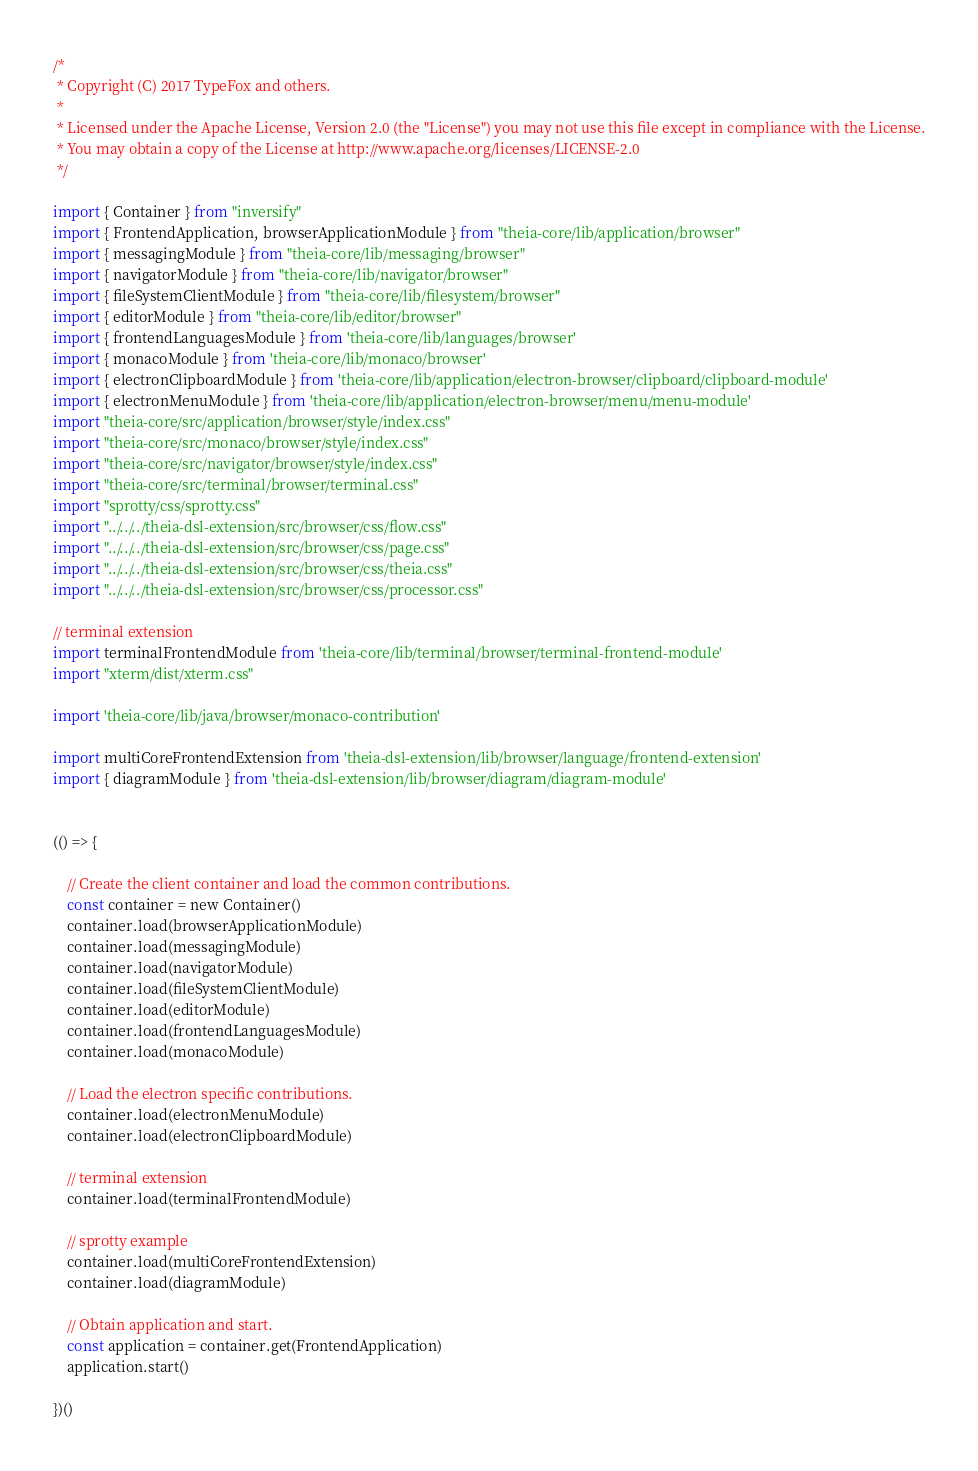Convert code to text. <code><loc_0><loc_0><loc_500><loc_500><_TypeScript_>/*
 * Copyright (C) 2017 TypeFox and others.
 *
 * Licensed under the Apache License, Version 2.0 (the "License") you may not use this file except in compliance with the License.
 * You may obtain a copy of the License at http://www.apache.org/licenses/LICENSE-2.0
 */

import { Container } from "inversify"
import { FrontendApplication, browserApplicationModule } from "theia-core/lib/application/browser"
import { messagingModule } from "theia-core/lib/messaging/browser"
import { navigatorModule } from "theia-core/lib/navigator/browser"
import { fileSystemClientModule } from "theia-core/lib/filesystem/browser"
import { editorModule } from "theia-core/lib/editor/browser"
import { frontendLanguagesModule } from 'theia-core/lib/languages/browser'
import { monacoModule } from 'theia-core/lib/monaco/browser'
import { electronClipboardModule } from 'theia-core/lib/application/electron-browser/clipboard/clipboard-module'
import { electronMenuModule } from 'theia-core/lib/application/electron-browser/menu/menu-module'
import "theia-core/src/application/browser/style/index.css"
import "theia-core/src/monaco/browser/style/index.css"
import "theia-core/src/navigator/browser/style/index.css"
import "theia-core/src/terminal/browser/terminal.css"
import "sprotty/css/sprotty.css"
import "../../../theia-dsl-extension/src/browser/css/flow.css"
import "../../../theia-dsl-extension/src/browser/css/page.css"
import "../../../theia-dsl-extension/src/browser/css/theia.css"
import "../../../theia-dsl-extension/src/browser/css/processor.css"

// terminal extension
import terminalFrontendModule from 'theia-core/lib/terminal/browser/terminal-frontend-module'
import "xterm/dist/xterm.css"

import 'theia-core/lib/java/browser/monaco-contribution'

import multiCoreFrontendExtension from 'theia-dsl-extension/lib/browser/language/frontend-extension'
import { diagramModule } from 'theia-dsl-extension/lib/browser/diagram/diagram-module'


(() => {

    // Create the client container and load the common contributions.
    const container = new Container()
    container.load(browserApplicationModule)
    container.load(messagingModule)
    container.load(navigatorModule)
    container.load(fileSystemClientModule)
    container.load(editorModule)
    container.load(frontendLanguagesModule)
    container.load(monacoModule)

    // Load the electron specific contributions.
    container.load(electronMenuModule)
    container.load(electronClipboardModule)

    // terminal extension
    container.load(terminalFrontendModule)

    // sprotty example
    container.load(multiCoreFrontendExtension)
    container.load(diagramModule)

    // Obtain application and start.
    const application = container.get(FrontendApplication)
    application.start()

})()</code> 